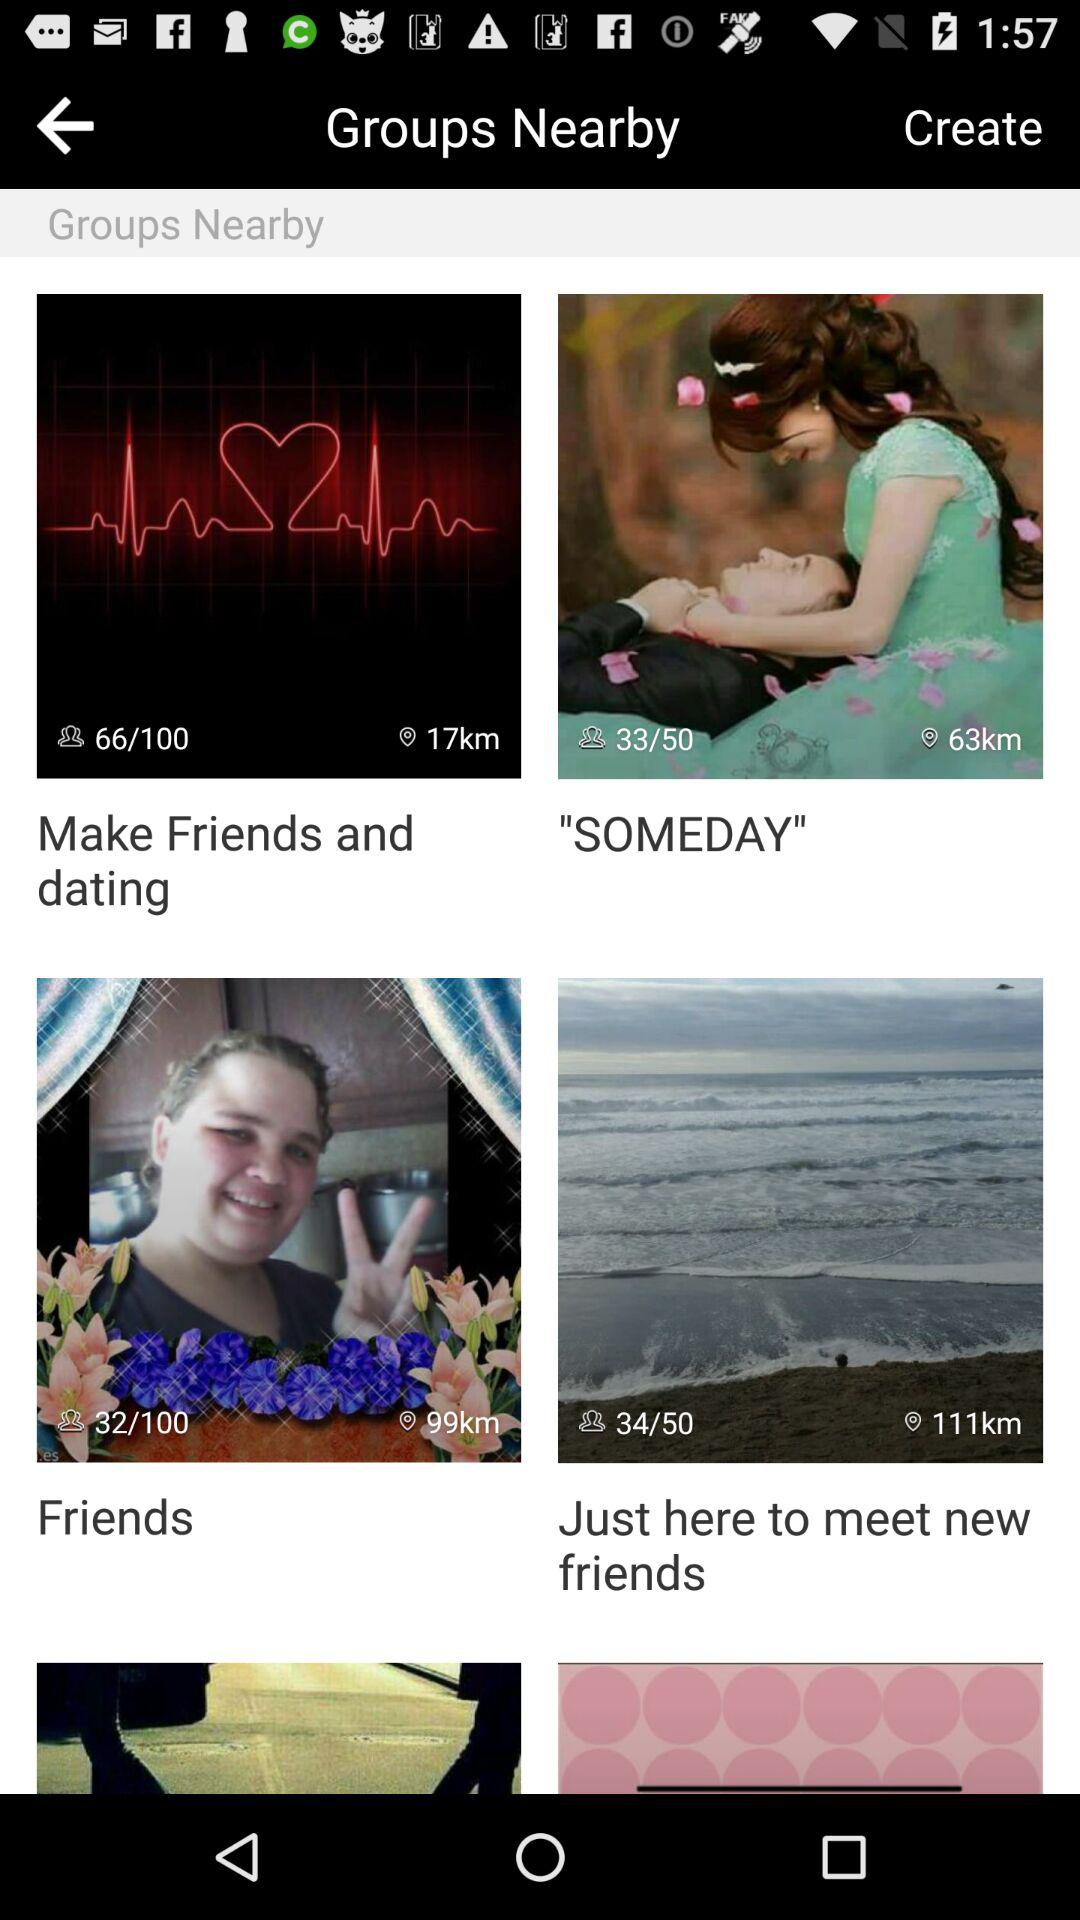How many total number of slides are there for Make Friends and dating?
When the provided information is insufficient, respond with <no answer>. <no answer> 